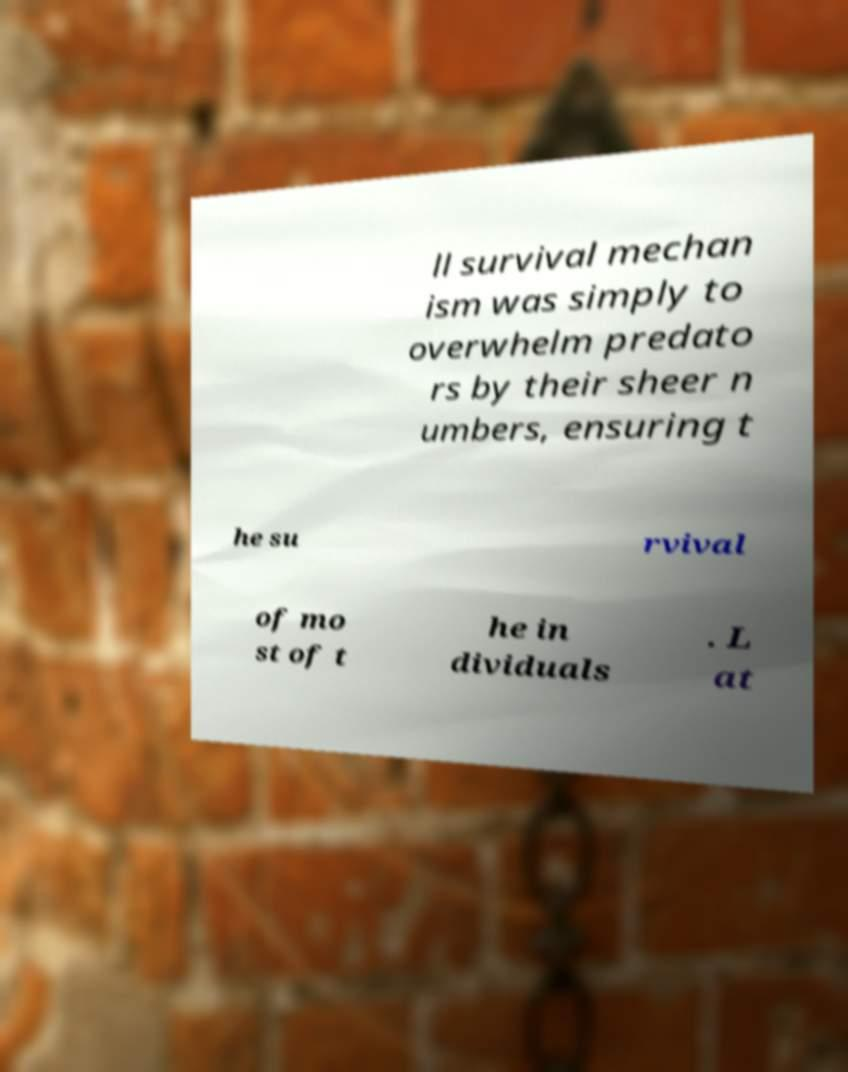There's text embedded in this image that I need extracted. Can you transcribe it verbatim? ll survival mechan ism was simply to overwhelm predato rs by their sheer n umbers, ensuring t he su rvival of mo st of t he in dividuals . L at 